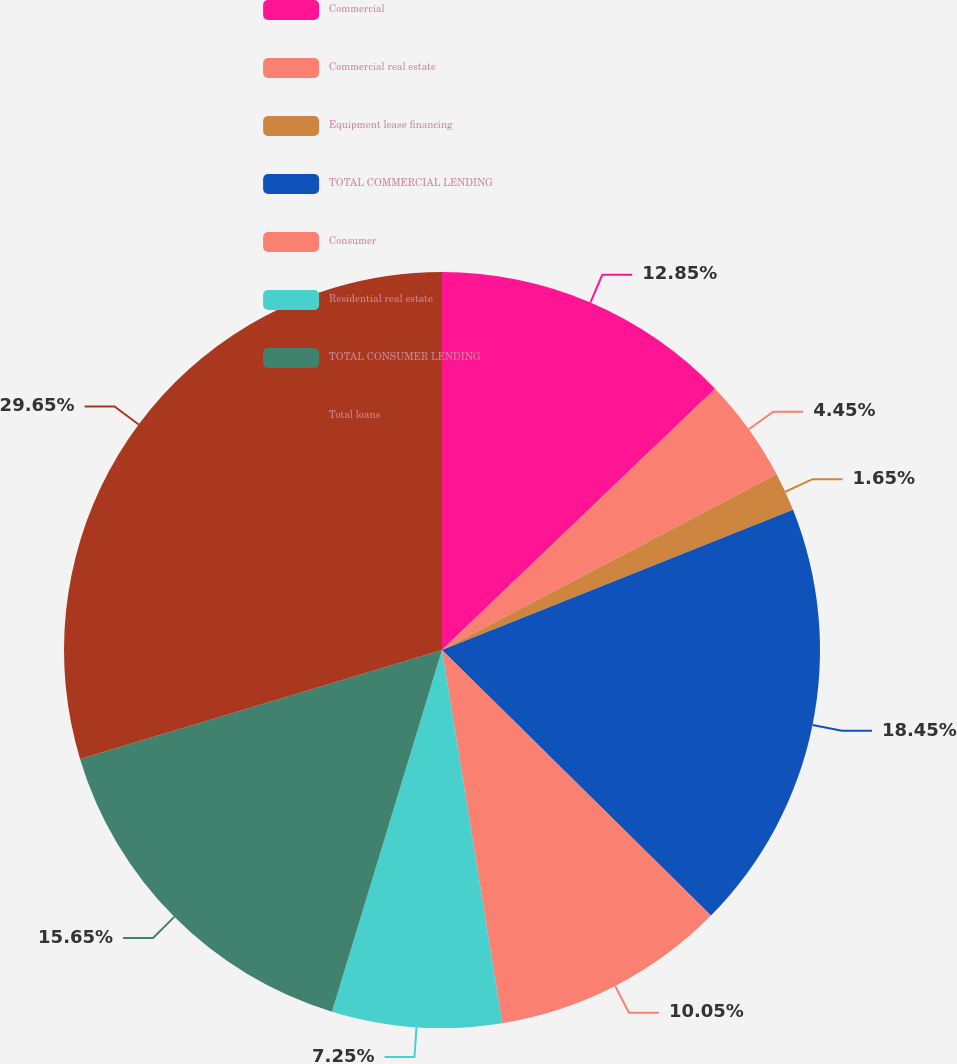<chart> <loc_0><loc_0><loc_500><loc_500><pie_chart><fcel>Commercial<fcel>Commercial real estate<fcel>Equipment lease financing<fcel>TOTAL COMMERCIAL LENDING<fcel>Consumer<fcel>Residential real estate<fcel>TOTAL CONSUMER LENDING<fcel>Total loans<nl><fcel>12.85%<fcel>4.45%<fcel>1.65%<fcel>18.45%<fcel>10.05%<fcel>7.25%<fcel>15.65%<fcel>29.65%<nl></chart> 